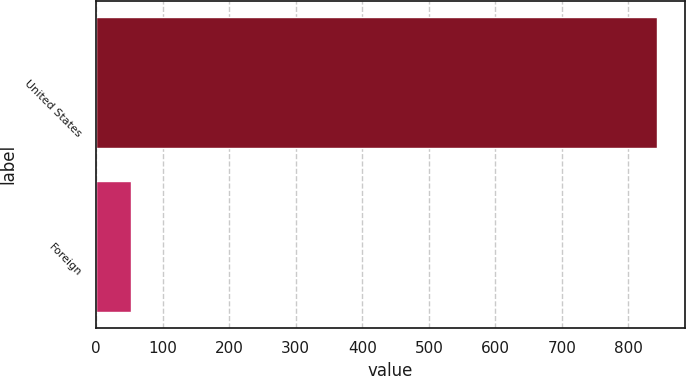Convert chart to OTSL. <chart><loc_0><loc_0><loc_500><loc_500><bar_chart><fcel>United States<fcel>Foreign<nl><fcel>842.6<fcel>52.7<nl></chart> 